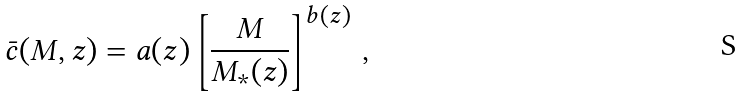Convert formula to latex. <formula><loc_0><loc_0><loc_500><loc_500>\bar { c } ( M , z ) = a ( z ) \left [ \frac { M } { M _ { * } ( z ) } \right ] ^ { b ( z ) } \, ,</formula> 